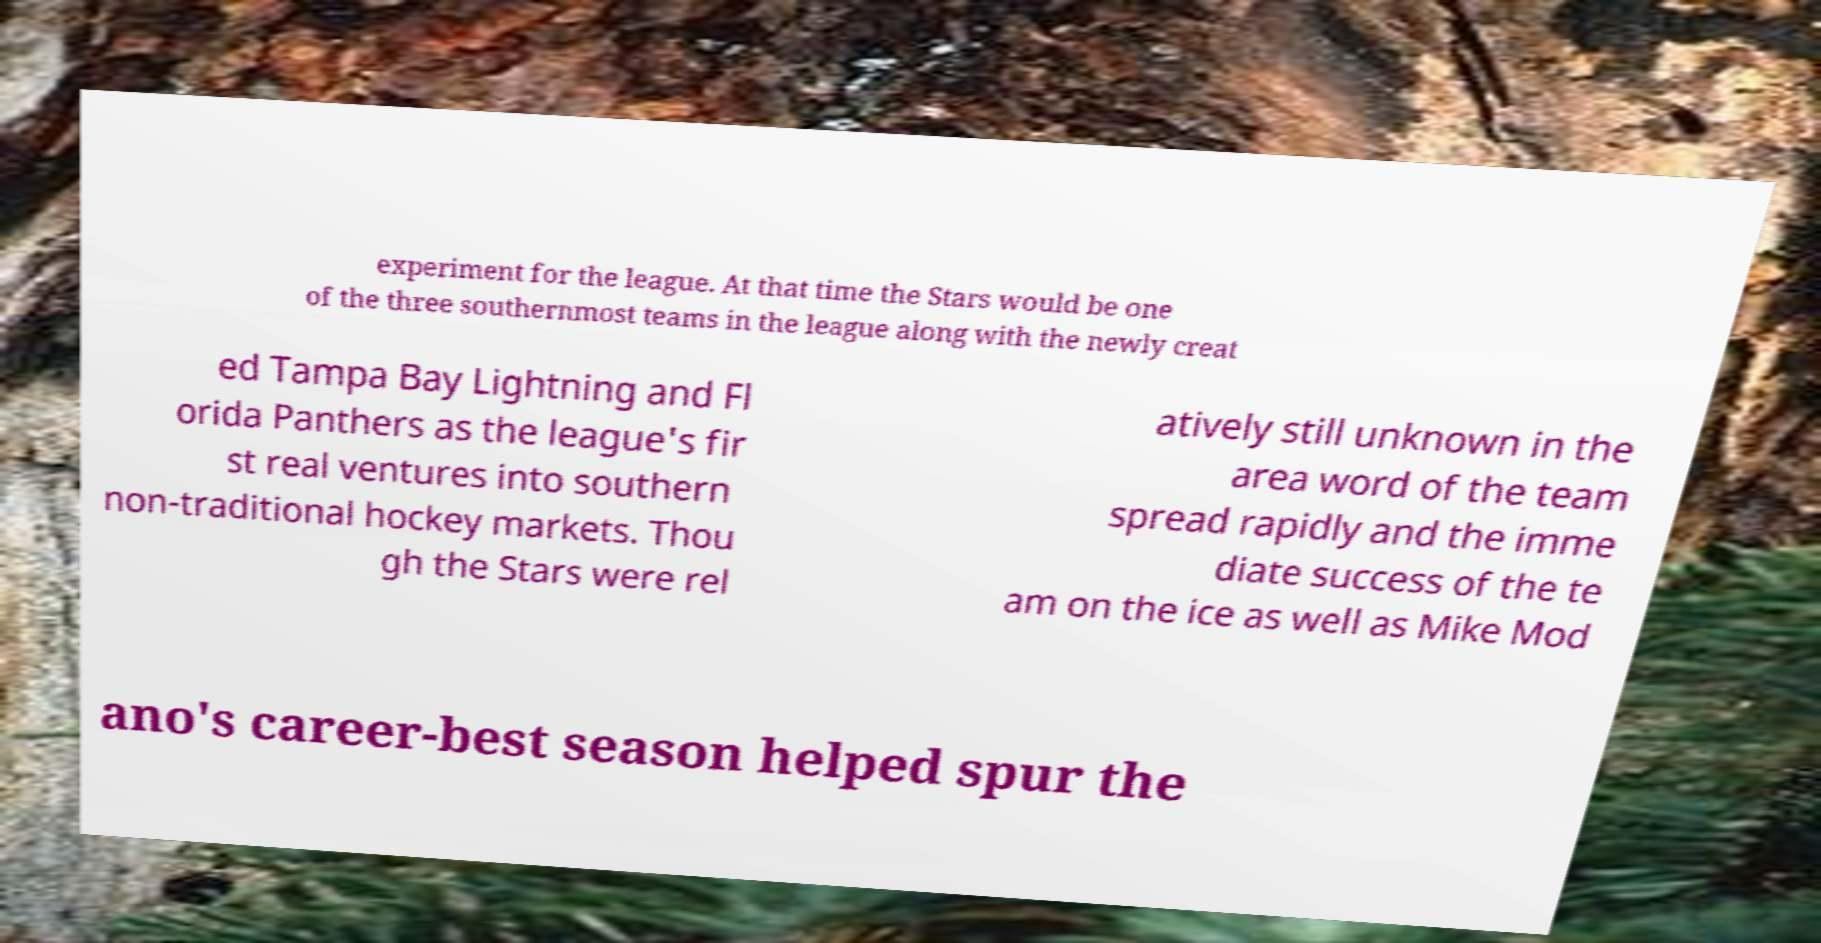There's text embedded in this image that I need extracted. Can you transcribe it verbatim? experiment for the league. At that time the Stars would be one of the three southernmost teams in the league along with the newly creat ed Tampa Bay Lightning and Fl orida Panthers as the league's fir st real ventures into southern non-traditional hockey markets. Thou gh the Stars were rel atively still unknown in the area word of the team spread rapidly and the imme diate success of the te am on the ice as well as Mike Mod ano's career-best season helped spur the 